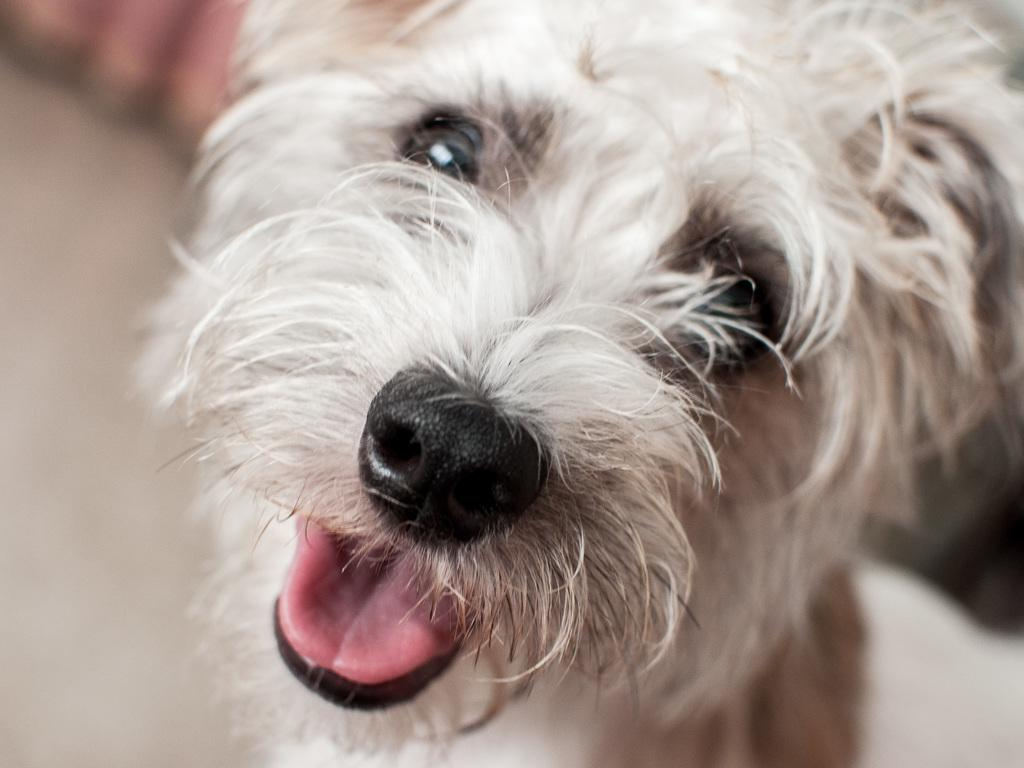What type of animal is in the image? There is a dog in the image. Can you describe the background of the image? The background of the image is blurry. What type of dock can be seen in the image? There is no dock present in the image; it features a dog and a blurry background. How does the dog rub against the waves in the image? There are no waves present in the image, and the dog is not shown rubbing against anything. 